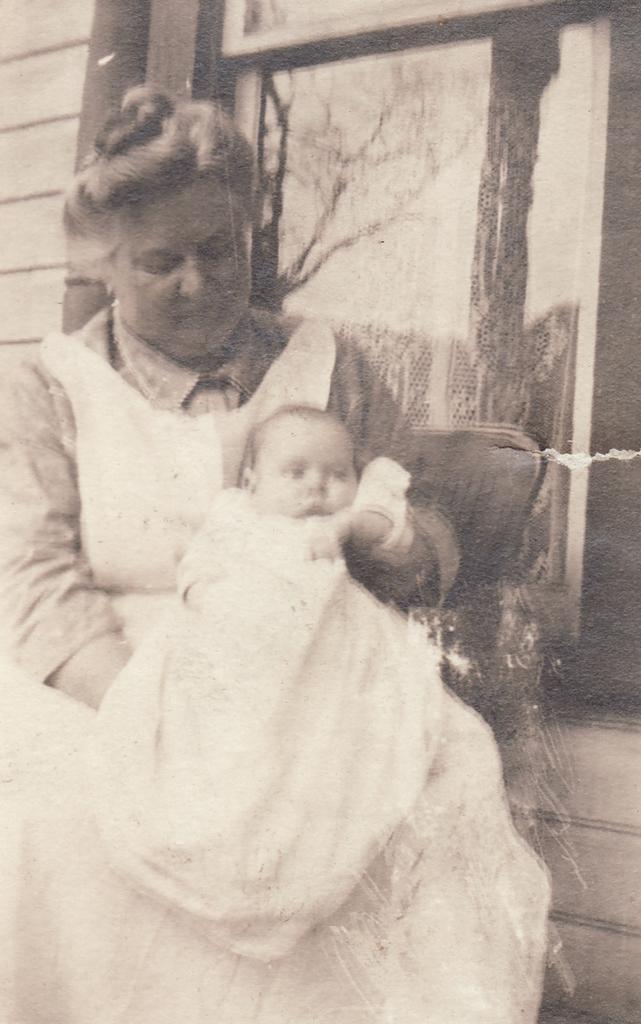How would you summarize this image in a sentence or two? Here, we can see a photo, in that photo we can see a woman holding a baby and we can see the wall. 